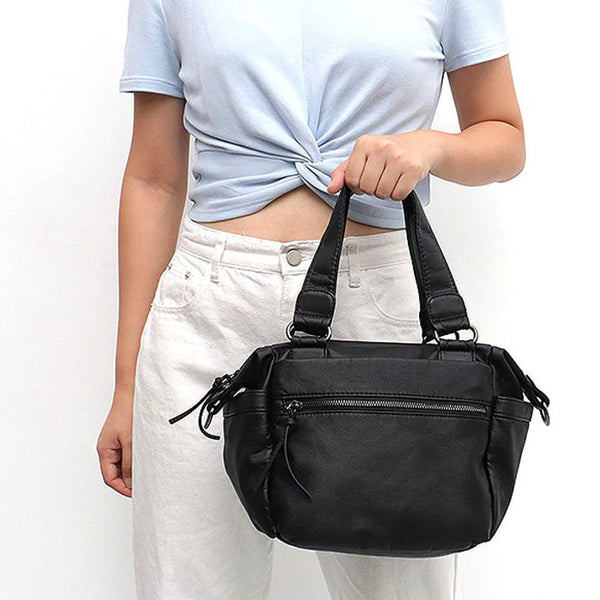Considering the style and design of the handbag, what can be inferred about its functionality and potential use scenarios? Based on the handbag's design, it can be inferred that it is a versatile and practical accessory likely intended for everyday use. The main compartment is spacious enough to accommodate essential items such as a wallet, keys, phone, makeup, and perhaps a small notebook or tablet. The additional external pocket offers convenient access for smaller items, such as a transit card or lip balm, which you might need to grab quickly. The medium size ensures it is not too bulky, making it ideal for a variety of activities including shopping, running errands, commuting to work or school, and even casual outings with friends. The option of carrying it by hand or over the shoulder with straps adds to its convenience, allowing for a comfortable carrying experience in different situations. 